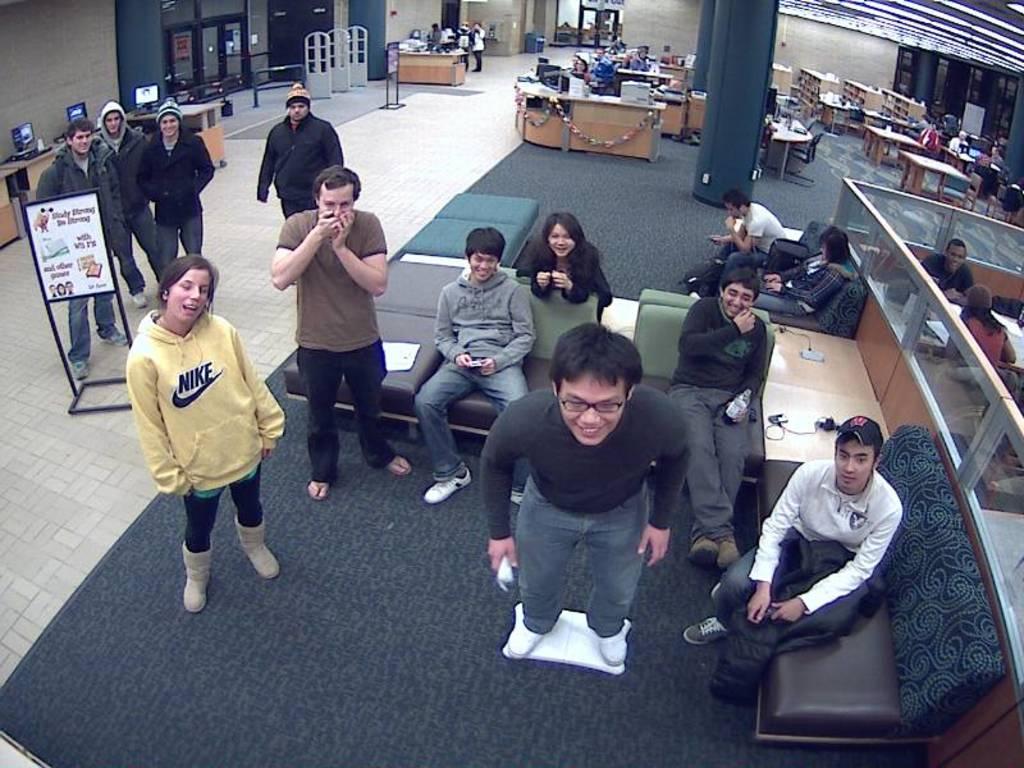Could you give a brief overview of what you see in this image? In this image we can see people standing on the floor and some are sitting on the chairs and tables are placed in front of them. On the tables we can see desktops, papers and books. 